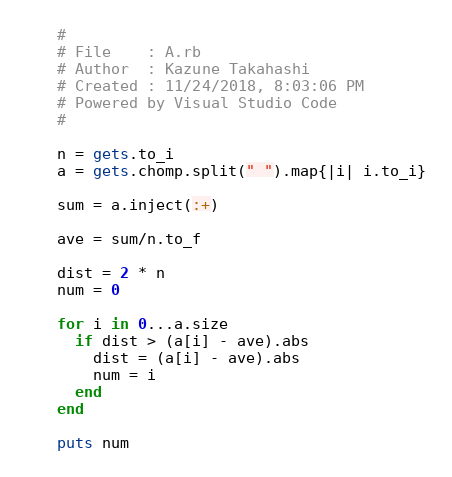Convert code to text. <code><loc_0><loc_0><loc_500><loc_500><_Ruby_>#
# File    : A.rb
# Author  : Kazune Takahashi
# Created : 11/24/2018, 8:03:06 PM
# Powered by Visual Studio Code
#

n = gets.to_i
a = gets.chomp.split(" ").map{|i| i.to_i}

sum = a.inject(:+)

ave = sum/n.to_f

dist = 2 * n
num = 0

for i in 0...a.size
  if dist > (a[i] - ave).abs
    dist = (a[i] - ave).abs
    num = i
  end
end

puts num
</code> 